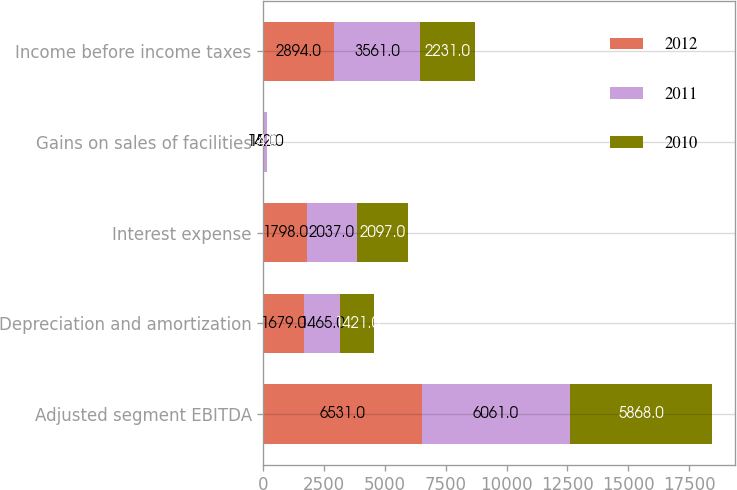Convert chart to OTSL. <chart><loc_0><loc_0><loc_500><loc_500><stacked_bar_chart><ecel><fcel>Adjusted segment EBITDA<fcel>Depreciation and amortization<fcel>Interest expense<fcel>Gains on sales of facilities<fcel>Income before income taxes<nl><fcel>2012<fcel>6531<fcel>1679<fcel>1798<fcel>15<fcel>2894<nl><fcel>2011<fcel>6061<fcel>1465<fcel>2037<fcel>142<fcel>3561<nl><fcel>2010<fcel>5868<fcel>1421<fcel>2097<fcel>4<fcel>2231<nl></chart> 